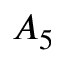Convert formula to latex. <formula><loc_0><loc_0><loc_500><loc_500>A _ { 5 }</formula> 